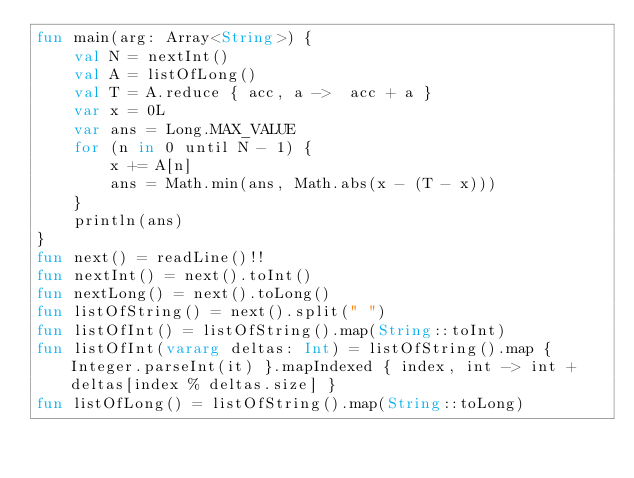<code> <loc_0><loc_0><loc_500><loc_500><_Kotlin_>fun main(arg: Array<String>) {
    val N = nextInt()
    val A = listOfLong()
    val T = A.reduce { acc, a ->  acc + a }
    var x = 0L
    var ans = Long.MAX_VALUE
    for (n in 0 until N - 1) {
        x += A[n]
        ans = Math.min(ans, Math.abs(x - (T - x)))
    }
    println(ans)
}
fun next() = readLine()!!
fun nextInt() = next().toInt()
fun nextLong() = next().toLong()
fun listOfString() = next().split(" ")
fun listOfInt() = listOfString().map(String::toInt)
fun listOfInt(vararg deltas: Int) = listOfString().map { Integer.parseInt(it) }.mapIndexed { index, int -> int + deltas[index % deltas.size] }
fun listOfLong() = listOfString().map(String::toLong)

</code> 